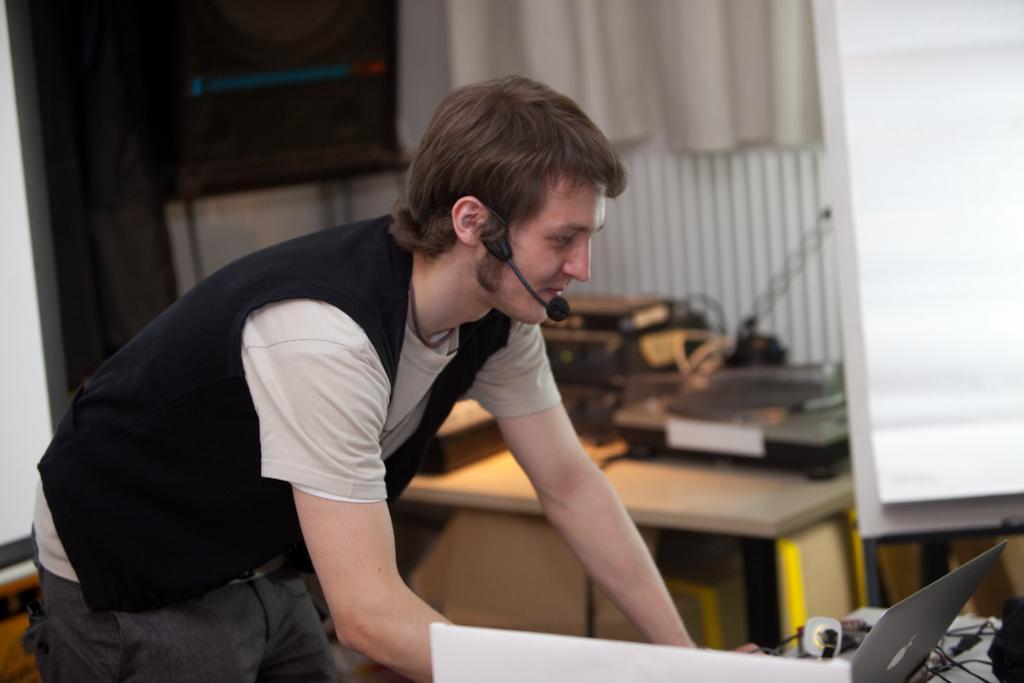How would you summarize this image in a sentence or two? In this image at front there is a person standing in front of the table. On top of the table there is a laptop and few other objects. Behind the person there is another table. On top of it there are few objects. At the back side there are curtains and we can see a speaker beside the curtains. 